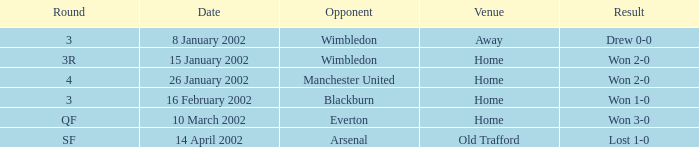What is the sphere with an opponent with blackburn? 3.0. 